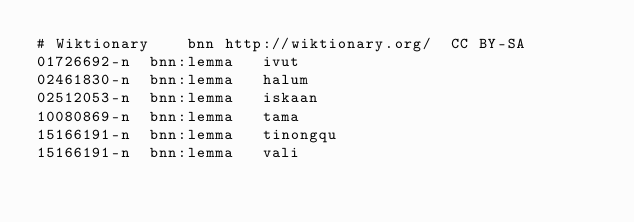<code> <loc_0><loc_0><loc_500><loc_500><_SQL_># Wiktionary	bnn	http://wiktionary.org/	CC BY-SA
01726692-n	bnn:lemma	ivut
02461830-n	bnn:lemma	halum
02512053-n	bnn:lemma	iskaan
10080869-n	bnn:lemma	tama
15166191-n	bnn:lemma	tinongqu
15166191-n	bnn:lemma	vali
</code> 